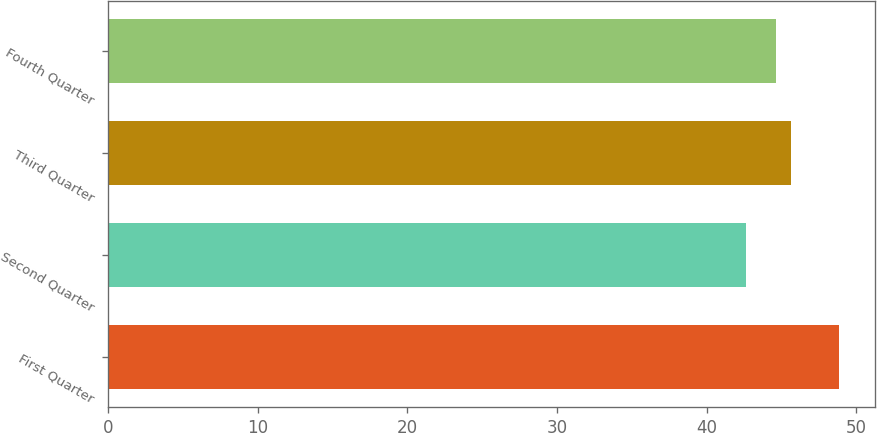Convert chart. <chart><loc_0><loc_0><loc_500><loc_500><bar_chart><fcel>First Quarter<fcel>Second Quarter<fcel>Third Quarter<fcel>Fourth Quarter<nl><fcel>48.83<fcel>42.65<fcel>45.63<fcel>44.62<nl></chart> 